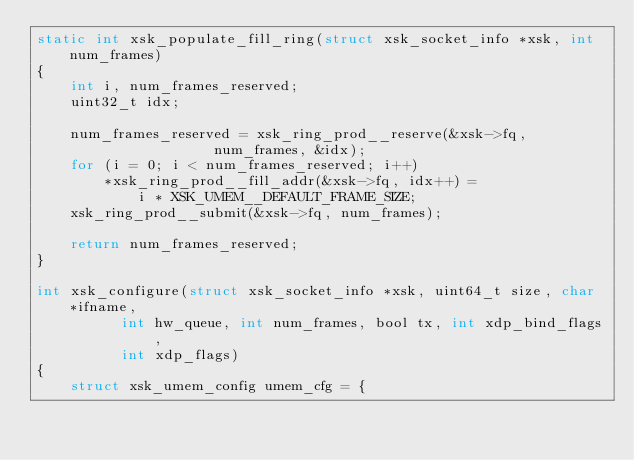Convert code to text. <code><loc_0><loc_0><loc_500><loc_500><_C_>static int xsk_populate_fill_ring(struct xsk_socket_info *xsk, int num_frames)
{
	int i, num_frames_reserved;
	uint32_t idx;

	num_frames_reserved = xsk_ring_prod__reserve(&xsk->fq,
				     num_frames, &idx);
	for (i = 0; i < num_frames_reserved; i++)
		*xsk_ring_prod__fill_addr(&xsk->fq, idx++) =
			i * XSK_UMEM__DEFAULT_FRAME_SIZE;
	xsk_ring_prod__submit(&xsk->fq, num_frames);

	return num_frames_reserved;
}

int xsk_configure(struct xsk_socket_info *xsk, uint64_t size, char *ifname,
		  int hw_queue, int num_frames, bool tx, int xdp_bind_flags,
		  int xdp_flags)
{
	struct xsk_umem_config umem_cfg = {</code> 